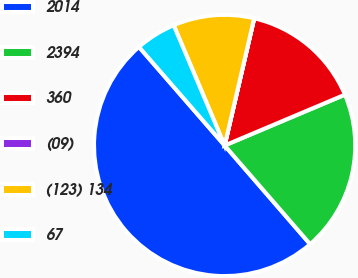<chart> <loc_0><loc_0><loc_500><loc_500><pie_chart><fcel>2014<fcel>2394<fcel>360<fcel>(09)<fcel>(123) 134<fcel>67<nl><fcel>49.97%<fcel>20.0%<fcel>15.0%<fcel>0.01%<fcel>10.01%<fcel>5.01%<nl></chart> 